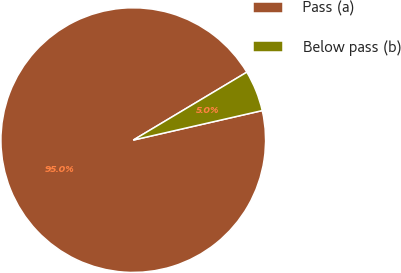Convert chart. <chart><loc_0><loc_0><loc_500><loc_500><pie_chart><fcel>Pass (a)<fcel>Below pass (b)<nl><fcel>95.0%<fcel>5.0%<nl></chart> 